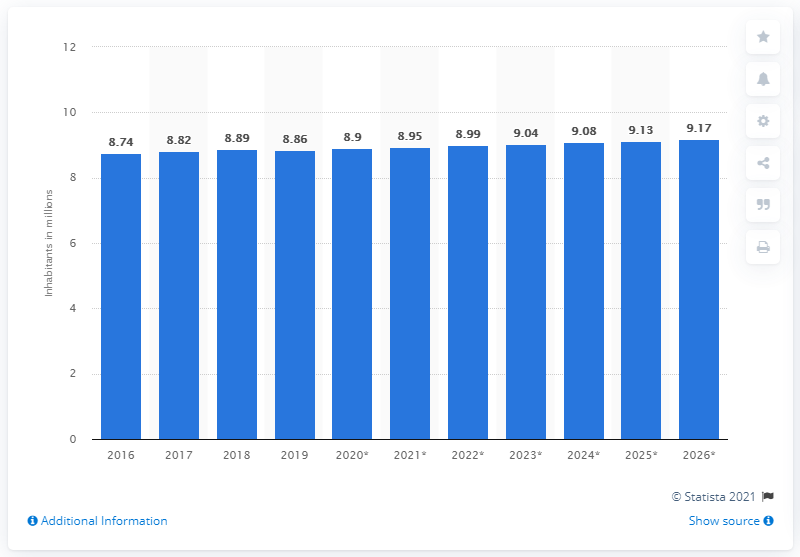Mention a couple of crucial points in this snapshot. In 2019, the population of Austria was 8.9 million. 